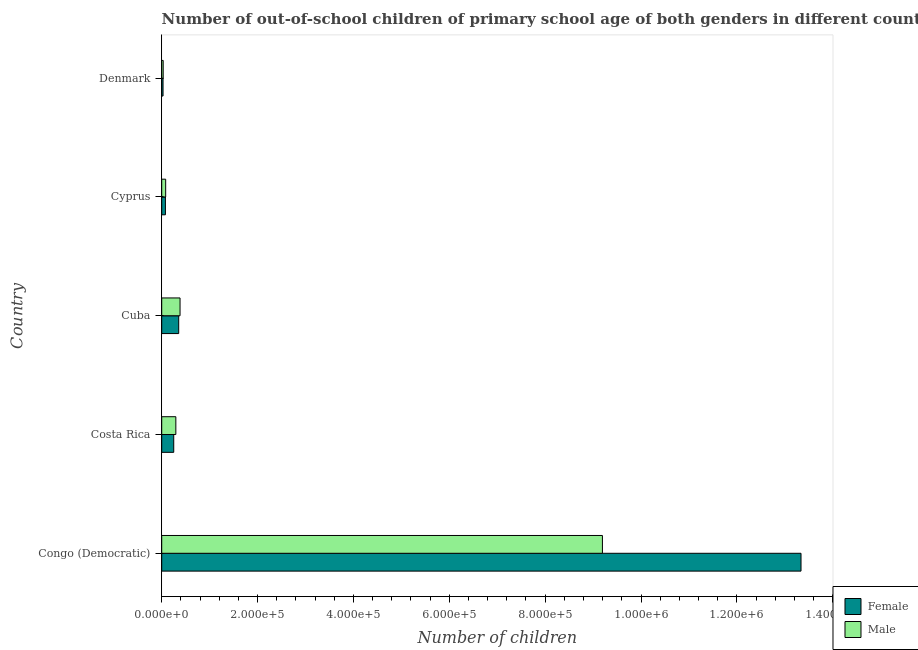Are the number of bars on each tick of the Y-axis equal?
Ensure brevity in your answer.  Yes. How many bars are there on the 3rd tick from the bottom?
Offer a very short reply. 2. What is the label of the 3rd group of bars from the top?
Your response must be concise. Cuba. What is the number of male out-of-school students in Cyprus?
Your answer should be compact. 8279. Across all countries, what is the maximum number of male out-of-school students?
Keep it short and to the point. 9.19e+05. Across all countries, what is the minimum number of female out-of-school students?
Offer a terse response. 2771. In which country was the number of female out-of-school students maximum?
Keep it short and to the point. Congo (Democratic). In which country was the number of male out-of-school students minimum?
Ensure brevity in your answer.  Denmark. What is the total number of female out-of-school students in the graph?
Offer a terse response. 1.40e+06. What is the difference between the number of male out-of-school students in Cyprus and that in Denmark?
Offer a very short reply. 5188. What is the difference between the number of female out-of-school students in Cuba and the number of male out-of-school students in Denmark?
Ensure brevity in your answer.  3.24e+04. What is the average number of female out-of-school students per country?
Offer a very short reply. 2.81e+05. What is the difference between the number of female out-of-school students and number of male out-of-school students in Cuba?
Your response must be concise. -2784. What is the ratio of the number of male out-of-school students in Congo (Democratic) to that in Costa Rica?
Provide a succinct answer. 31.2. Is the difference between the number of female out-of-school students in Cuba and Cyprus greater than the difference between the number of male out-of-school students in Cuba and Cyprus?
Make the answer very short. No. What is the difference between the highest and the second highest number of female out-of-school students?
Make the answer very short. 1.30e+06. What is the difference between the highest and the lowest number of male out-of-school students?
Your answer should be very brief. 9.16e+05. In how many countries, is the number of female out-of-school students greater than the average number of female out-of-school students taken over all countries?
Offer a very short reply. 1. Are all the bars in the graph horizontal?
Give a very brief answer. Yes. How many countries are there in the graph?
Your answer should be very brief. 5. What is the difference between two consecutive major ticks on the X-axis?
Make the answer very short. 2.00e+05. Are the values on the major ticks of X-axis written in scientific E-notation?
Ensure brevity in your answer.  Yes. Does the graph contain any zero values?
Provide a short and direct response. No. Where does the legend appear in the graph?
Provide a short and direct response. Bottom right. How are the legend labels stacked?
Give a very brief answer. Vertical. What is the title of the graph?
Offer a very short reply. Number of out-of-school children of primary school age of both genders in different countries. What is the label or title of the X-axis?
Your answer should be very brief. Number of children. What is the Number of children of Female in Congo (Democratic)?
Keep it short and to the point. 1.33e+06. What is the Number of children in Male in Congo (Democratic)?
Offer a terse response. 9.19e+05. What is the Number of children of Female in Costa Rica?
Provide a short and direct response. 2.51e+04. What is the Number of children in Male in Costa Rica?
Provide a short and direct response. 2.95e+04. What is the Number of children in Female in Cuba?
Offer a terse response. 3.55e+04. What is the Number of children in Male in Cuba?
Your answer should be compact. 3.82e+04. What is the Number of children in Female in Cyprus?
Provide a short and direct response. 7733. What is the Number of children of Male in Cyprus?
Give a very brief answer. 8279. What is the Number of children in Female in Denmark?
Make the answer very short. 2771. What is the Number of children in Male in Denmark?
Ensure brevity in your answer.  3091. Across all countries, what is the maximum Number of children in Female?
Offer a terse response. 1.33e+06. Across all countries, what is the maximum Number of children of Male?
Give a very brief answer. 9.19e+05. Across all countries, what is the minimum Number of children of Female?
Your answer should be compact. 2771. Across all countries, what is the minimum Number of children of Male?
Keep it short and to the point. 3091. What is the total Number of children of Female in the graph?
Keep it short and to the point. 1.40e+06. What is the total Number of children of Male in the graph?
Provide a short and direct response. 9.99e+05. What is the difference between the Number of children in Female in Congo (Democratic) and that in Costa Rica?
Provide a short and direct response. 1.31e+06. What is the difference between the Number of children in Male in Congo (Democratic) and that in Costa Rica?
Keep it short and to the point. 8.90e+05. What is the difference between the Number of children in Female in Congo (Democratic) and that in Cuba?
Offer a very short reply. 1.30e+06. What is the difference between the Number of children in Male in Congo (Democratic) and that in Cuba?
Make the answer very short. 8.81e+05. What is the difference between the Number of children in Female in Congo (Democratic) and that in Cyprus?
Ensure brevity in your answer.  1.33e+06. What is the difference between the Number of children in Male in Congo (Democratic) and that in Cyprus?
Provide a short and direct response. 9.11e+05. What is the difference between the Number of children in Female in Congo (Democratic) and that in Denmark?
Offer a terse response. 1.33e+06. What is the difference between the Number of children in Male in Congo (Democratic) and that in Denmark?
Your answer should be very brief. 9.16e+05. What is the difference between the Number of children of Female in Costa Rica and that in Cuba?
Ensure brevity in your answer.  -1.04e+04. What is the difference between the Number of children in Male in Costa Rica and that in Cuba?
Provide a succinct answer. -8764. What is the difference between the Number of children in Female in Costa Rica and that in Cyprus?
Your answer should be very brief. 1.74e+04. What is the difference between the Number of children of Male in Costa Rica and that in Cyprus?
Provide a short and direct response. 2.12e+04. What is the difference between the Number of children in Female in Costa Rica and that in Denmark?
Your answer should be very brief. 2.23e+04. What is the difference between the Number of children of Male in Costa Rica and that in Denmark?
Keep it short and to the point. 2.64e+04. What is the difference between the Number of children of Female in Cuba and that in Cyprus?
Keep it short and to the point. 2.77e+04. What is the difference between the Number of children in Male in Cuba and that in Cyprus?
Offer a very short reply. 3.00e+04. What is the difference between the Number of children of Female in Cuba and that in Denmark?
Your answer should be compact. 3.27e+04. What is the difference between the Number of children of Male in Cuba and that in Denmark?
Make the answer very short. 3.51e+04. What is the difference between the Number of children in Female in Cyprus and that in Denmark?
Provide a succinct answer. 4962. What is the difference between the Number of children in Male in Cyprus and that in Denmark?
Your response must be concise. 5188. What is the difference between the Number of children in Female in Congo (Democratic) and the Number of children in Male in Costa Rica?
Offer a very short reply. 1.30e+06. What is the difference between the Number of children of Female in Congo (Democratic) and the Number of children of Male in Cuba?
Ensure brevity in your answer.  1.30e+06. What is the difference between the Number of children of Female in Congo (Democratic) and the Number of children of Male in Cyprus?
Offer a terse response. 1.33e+06. What is the difference between the Number of children in Female in Congo (Democratic) and the Number of children in Male in Denmark?
Offer a very short reply. 1.33e+06. What is the difference between the Number of children of Female in Costa Rica and the Number of children of Male in Cuba?
Ensure brevity in your answer.  -1.31e+04. What is the difference between the Number of children of Female in Costa Rica and the Number of children of Male in Cyprus?
Keep it short and to the point. 1.68e+04. What is the difference between the Number of children of Female in Costa Rica and the Number of children of Male in Denmark?
Keep it short and to the point. 2.20e+04. What is the difference between the Number of children in Female in Cuba and the Number of children in Male in Cyprus?
Offer a very short reply. 2.72e+04. What is the difference between the Number of children in Female in Cuba and the Number of children in Male in Denmark?
Your answer should be compact. 3.24e+04. What is the difference between the Number of children of Female in Cyprus and the Number of children of Male in Denmark?
Your answer should be very brief. 4642. What is the average Number of children in Female per country?
Provide a succinct answer. 2.81e+05. What is the average Number of children in Male per country?
Your answer should be compact. 2.00e+05. What is the difference between the Number of children of Female and Number of children of Male in Congo (Democratic)?
Your answer should be very brief. 4.14e+05. What is the difference between the Number of children of Female and Number of children of Male in Costa Rica?
Offer a terse response. -4385. What is the difference between the Number of children in Female and Number of children in Male in Cuba?
Your answer should be very brief. -2784. What is the difference between the Number of children of Female and Number of children of Male in Cyprus?
Offer a very short reply. -546. What is the difference between the Number of children of Female and Number of children of Male in Denmark?
Ensure brevity in your answer.  -320. What is the ratio of the Number of children of Female in Congo (Democratic) to that in Costa Rica?
Keep it short and to the point. 53.16. What is the ratio of the Number of children of Male in Congo (Democratic) to that in Costa Rica?
Your answer should be very brief. 31.2. What is the ratio of the Number of children in Female in Congo (Democratic) to that in Cuba?
Provide a succinct answer. 37.62. What is the ratio of the Number of children in Male in Congo (Democratic) to that in Cuba?
Make the answer very short. 24.05. What is the ratio of the Number of children of Female in Congo (Democratic) to that in Cyprus?
Give a very brief answer. 172.49. What is the ratio of the Number of children in Male in Congo (Democratic) to that in Cyprus?
Make the answer very short. 111.06. What is the ratio of the Number of children of Female in Congo (Democratic) to that in Denmark?
Offer a very short reply. 481.36. What is the ratio of the Number of children in Male in Congo (Democratic) to that in Denmark?
Provide a short and direct response. 297.47. What is the ratio of the Number of children of Female in Costa Rica to that in Cuba?
Your answer should be compact. 0.71. What is the ratio of the Number of children of Male in Costa Rica to that in Cuba?
Offer a very short reply. 0.77. What is the ratio of the Number of children of Female in Costa Rica to that in Cyprus?
Your response must be concise. 3.24. What is the ratio of the Number of children in Male in Costa Rica to that in Cyprus?
Your answer should be compact. 3.56. What is the ratio of the Number of children in Female in Costa Rica to that in Denmark?
Ensure brevity in your answer.  9.05. What is the ratio of the Number of children in Male in Costa Rica to that in Denmark?
Provide a succinct answer. 9.54. What is the ratio of the Number of children in Female in Cuba to that in Cyprus?
Your answer should be compact. 4.58. What is the ratio of the Number of children in Male in Cuba to that in Cyprus?
Keep it short and to the point. 4.62. What is the ratio of the Number of children of Female in Cuba to that in Denmark?
Provide a succinct answer. 12.79. What is the ratio of the Number of children of Male in Cuba to that in Denmark?
Ensure brevity in your answer.  12.37. What is the ratio of the Number of children in Female in Cyprus to that in Denmark?
Your answer should be very brief. 2.79. What is the ratio of the Number of children of Male in Cyprus to that in Denmark?
Keep it short and to the point. 2.68. What is the difference between the highest and the second highest Number of children in Female?
Provide a short and direct response. 1.30e+06. What is the difference between the highest and the second highest Number of children in Male?
Offer a very short reply. 8.81e+05. What is the difference between the highest and the lowest Number of children in Female?
Provide a short and direct response. 1.33e+06. What is the difference between the highest and the lowest Number of children in Male?
Your answer should be very brief. 9.16e+05. 